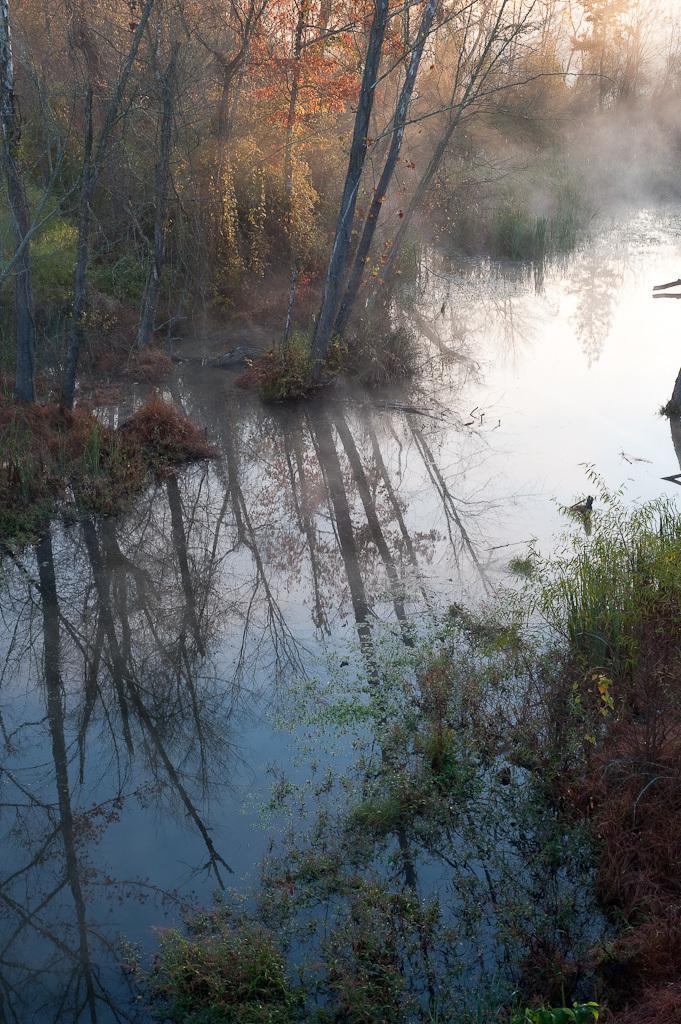In one or two sentences, can you explain what this image depicts? In this image at the bottom there is a river grass and some plants, in the background there are some trees. 